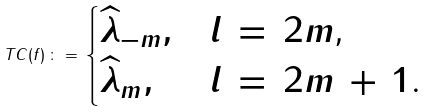Convert formula to latex. <formula><loc_0><loc_0><loc_500><loc_500>T C ( f ) \, \colon = \, \begin{cases} \widehat { \lambda } _ { - m } , & \text {$l \, = \, 2m$,} \\ \widehat { \lambda } _ { m } , & \text {$l \, = \, 2m \, + \, 1$.} \end{cases}</formula> 